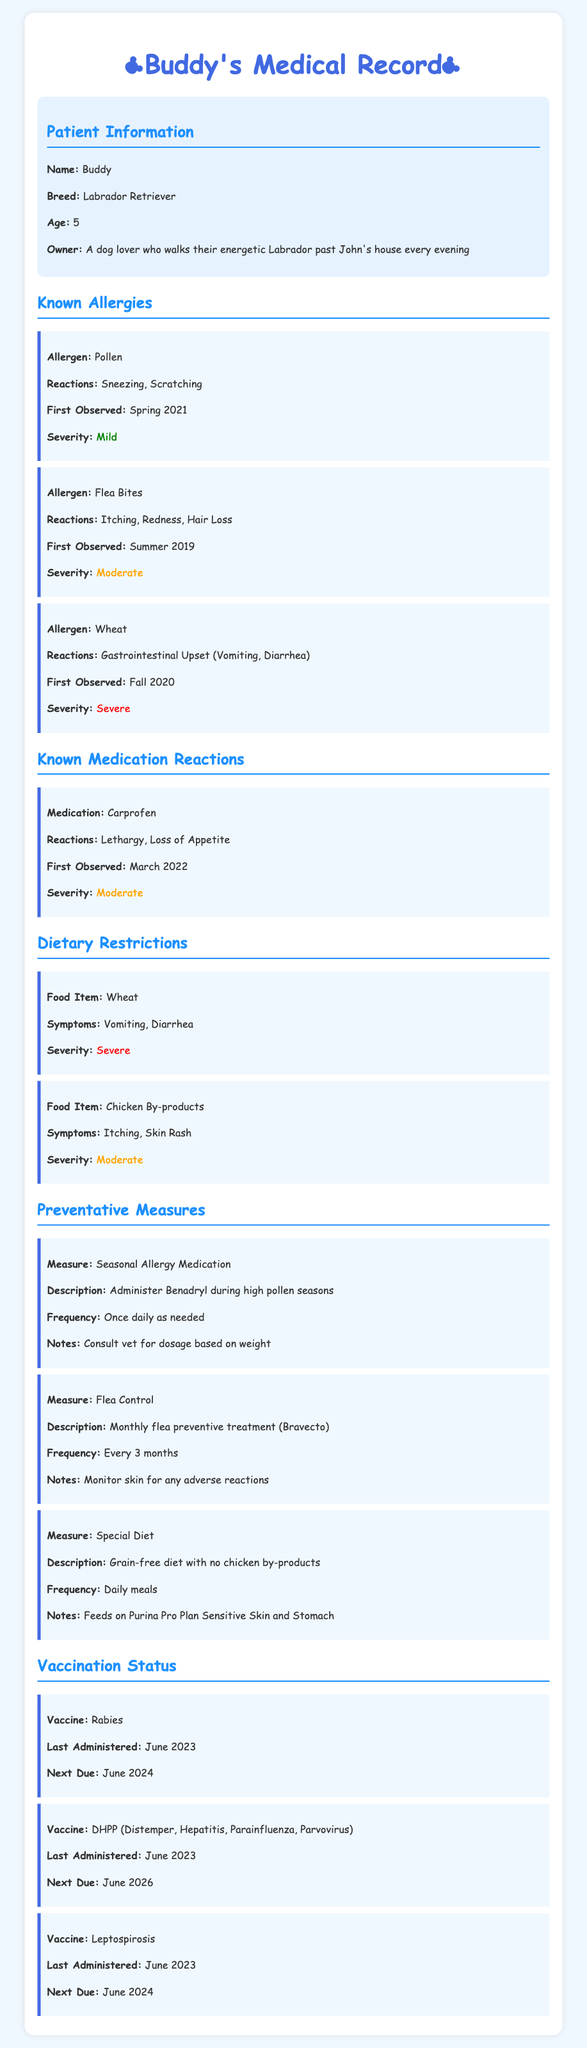What is Buddy's breed? The document specifies Buddy's breed in the patient information section.
Answer: Labrador Retriever What reaction does Buddy have to wheat? The document lists symptoms associated with Buddy's wheat allergy under dietary restrictions.
Answer: Gastrointestinal Upset (Vomiting, Diarrhea) When was the last time Buddy received the Rabies vaccine? The document provides the date of the last Rabies vaccination under vaccination status.
Answer: June 2023 What is one of the symptoms Buddy experiences due to flea bites? The document notes specific reactions to flea bites in the known allergies section.
Answer: Itching What is the severity level of Buddy's reaction to pollen? The severity of the reaction to pollen is indicated in the known allergies section of the document.
Answer: Mild What preventative measure is recommended for high pollen seasons? The document lists this preventative measure in the preventative measures section.
Answer: Seasonal Allergy Medication How often should Buddy receive flea preventive treatment? The frequency of flea control treatment is outlined in the preventative measures section.
Answer: Every 3 months What food item causes itching and skin rash in Buddy? This information can be found in the dietary restrictions section of the document.
Answer: Chicken By-products 